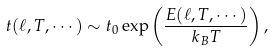Convert formula to latex. <formula><loc_0><loc_0><loc_500><loc_500>t ( \ell , T , \cdots ) \sim t _ { 0 } \exp \left ( \frac { E ( \ell , T , \cdots ) } { k _ { B } T } \right ) ,</formula> 